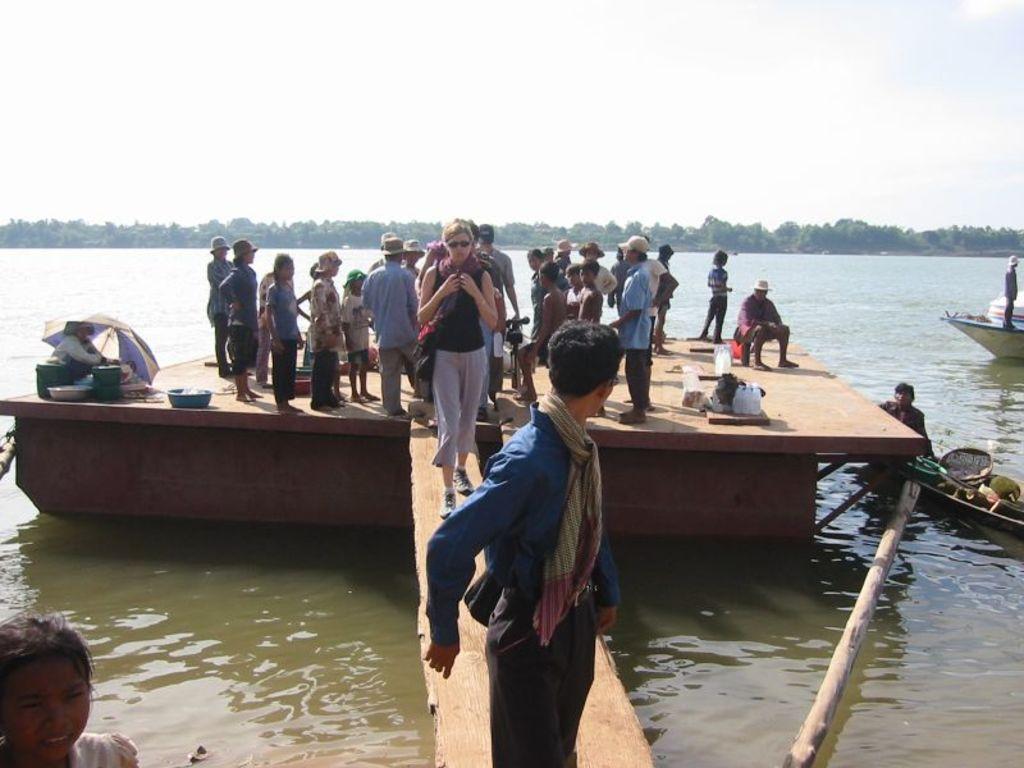Could you give a brief overview of what you see in this image? In this picture we can see a few people standing on a wooden surface. We can see a person sitting under an umbrella. There are dishes and other objects visible on this wooden surface. We can see two people on a walkway. There is a person on the right side. We can see a person and a few objects on the boat. There is a man standing on the boat. These boots are visible in the water. 